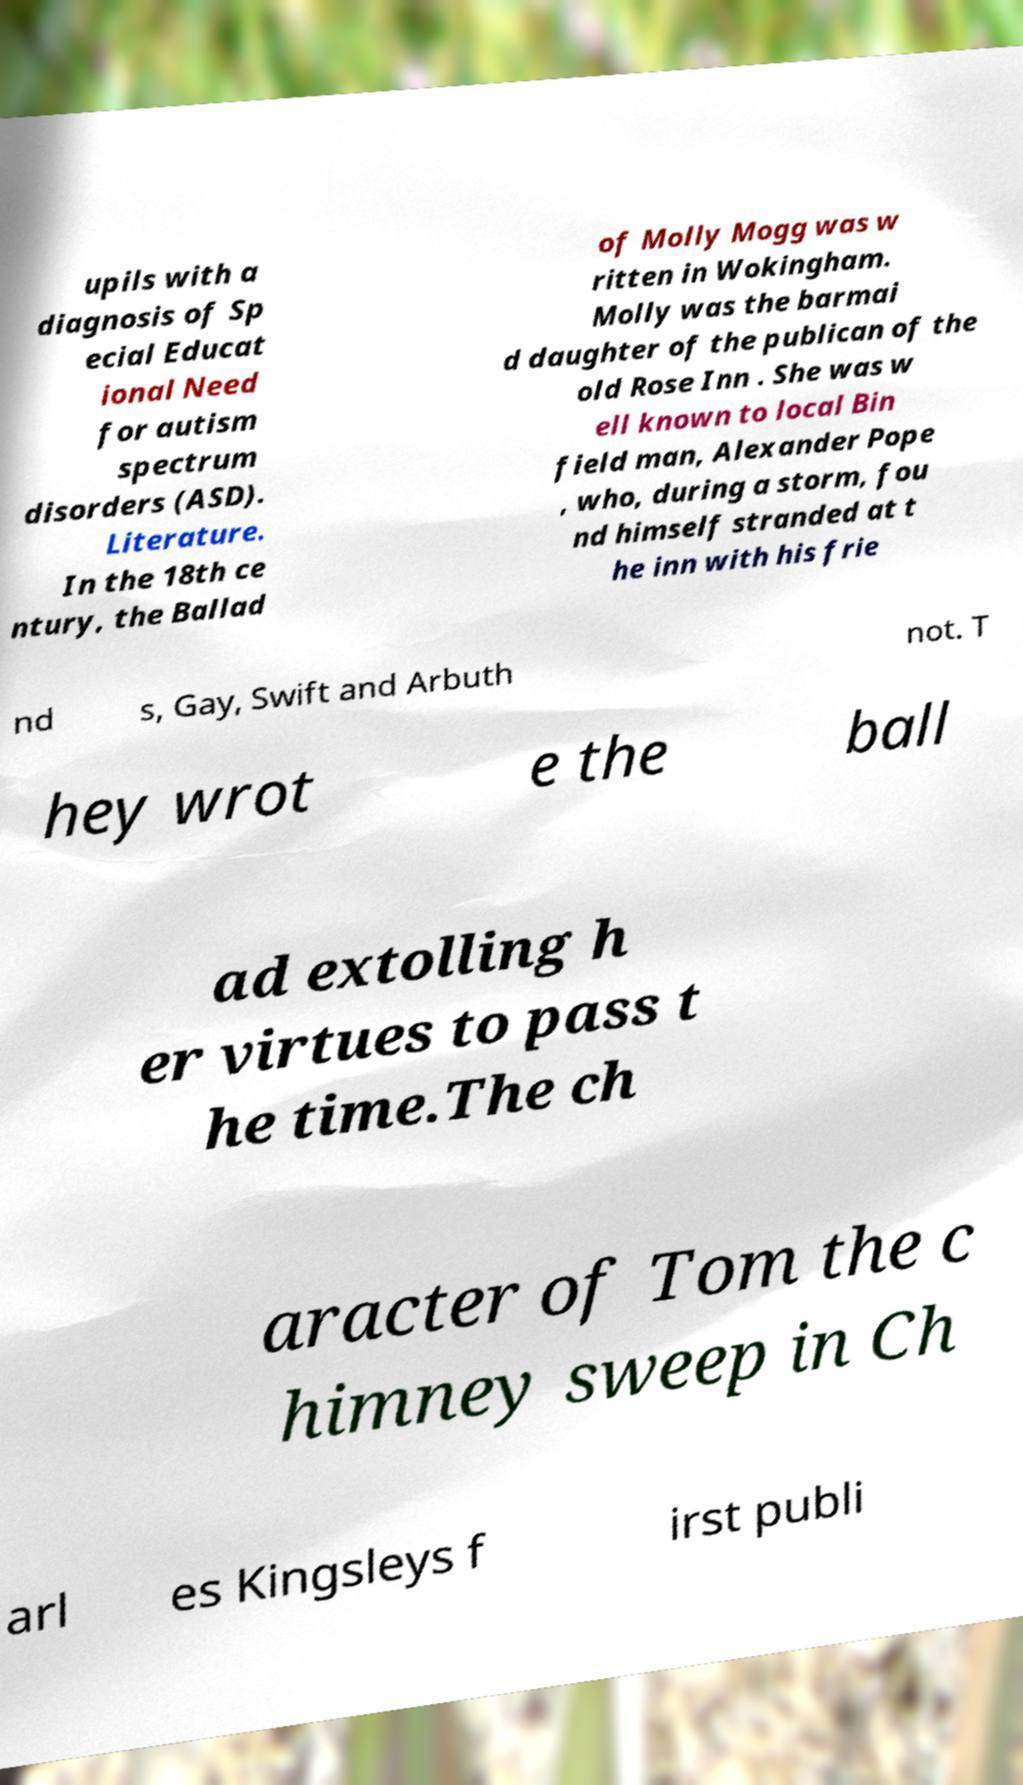For documentation purposes, I need the text within this image transcribed. Could you provide that? upils with a diagnosis of Sp ecial Educat ional Need for autism spectrum disorders (ASD). Literature. In the 18th ce ntury, the Ballad of Molly Mogg was w ritten in Wokingham. Molly was the barmai d daughter of the publican of the old Rose Inn . She was w ell known to local Bin field man, Alexander Pope , who, during a storm, fou nd himself stranded at t he inn with his frie nd s, Gay, Swift and Arbuth not. T hey wrot e the ball ad extolling h er virtues to pass t he time.The ch aracter of Tom the c himney sweep in Ch arl es Kingsleys f irst publi 